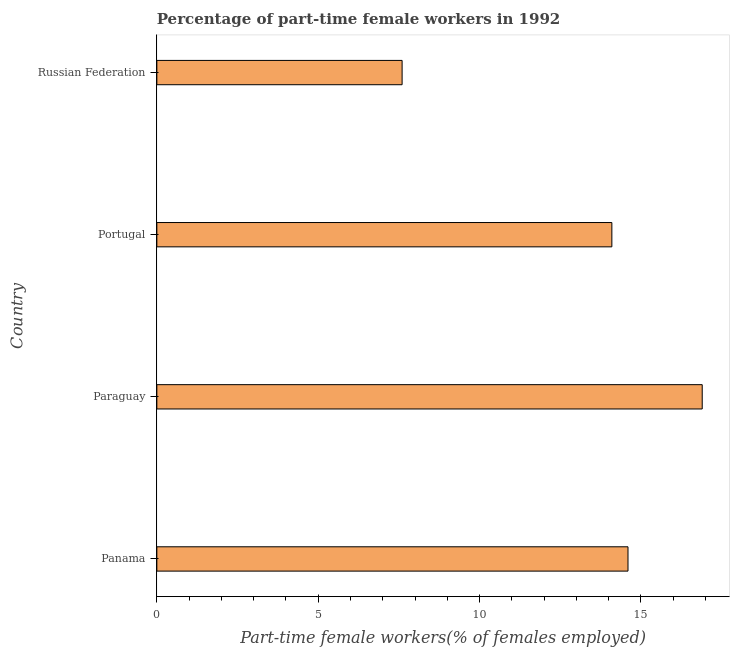What is the title of the graph?
Keep it short and to the point. Percentage of part-time female workers in 1992. What is the label or title of the X-axis?
Your response must be concise. Part-time female workers(% of females employed). What is the percentage of part-time female workers in Paraguay?
Ensure brevity in your answer.  16.9. Across all countries, what is the maximum percentage of part-time female workers?
Keep it short and to the point. 16.9. Across all countries, what is the minimum percentage of part-time female workers?
Provide a succinct answer. 7.6. In which country was the percentage of part-time female workers maximum?
Ensure brevity in your answer.  Paraguay. In which country was the percentage of part-time female workers minimum?
Offer a terse response. Russian Federation. What is the sum of the percentage of part-time female workers?
Ensure brevity in your answer.  53.2. What is the median percentage of part-time female workers?
Keep it short and to the point. 14.35. In how many countries, is the percentage of part-time female workers greater than 1 %?
Your answer should be compact. 4. What is the ratio of the percentage of part-time female workers in Portugal to that in Russian Federation?
Provide a succinct answer. 1.85. Is the sum of the percentage of part-time female workers in Portugal and Russian Federation greater than the maximum percentage of part-time female workers across all countries?
Offer a terse response. Yes. In how many countries, is the percentage of part-time female workers greater than the average percentage of part-time female workers taken over all countries?
Offer a very short reply. 3. What is the difference between two consecutive major ticks on the X-axis?
Your answer should be compact. 5. What is the Part-time female workers(% of females employed) in Panama?
Ensure brevity in your answer.  14.6. What is the Part-time female workers(% of females employed) of Paraguay?
Provide a short and direct response. 16.9. What is the Part-time female workers(% of females employed) of Portugal?
Offer a very short reply. 14.1. What is the Part-time female workers(% of females employed) in Russian Federation?
Give a very brief answer. 7.6. What is the difference between the Part-time female workers(% of females employed) in Panama and Paraguay?
Your response must be concise. -2.3. What is the difference between the Part-time female workers(% of females employed) in Panama and Portugal?
Offer a terse response. 0.5. What is the difference between the Part-time female workers(% of females employed) in Panama and Russian Federation?
Give a very brief answer. 7. What is the difference between the Part-time female workers(% of females employed) in Paraguay and Portugal?
Keep it short and to the point. 2.8. What is the ratio of the Part-time female workers(% of females employed) in Panama to that in Paraguay?
Your answer should be very brief. 0.86. What is the ratio of the Part-time female workers(% of females employed) in Panama to that in Portugal?
Your answer should be very brief. 1.03. What is the ratio of the Part-time female workers(% of females employed) in Panama to that in Russian Federation?
Offer a terse response. 1.92. What is the ratio of the Part-time female workers(% of females employed) in Paraguay to that in Portugal?
Keep it short and to the point. 1.2. What is the ratio of the Part-time female workers(% of females employed) in Paraguay to that in Russian Federation?
Ensure brevity in your answer.  2.22. What is the ratio of the Part-time female workers(% of females employed) in Portugal to that in Russian Federation?
Keep it short and to the point. 1.85. 